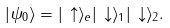Convert formula to latex. <formula><loc_0><loc_0><loc_500><loc_500>| \psi _ { 0 } \rangle = | \, \uparrow \rangle _ { e } | \, \downarrow \rangle _ { 1 } | \, \downarrow \rangle _ { 2 } .</formula> 